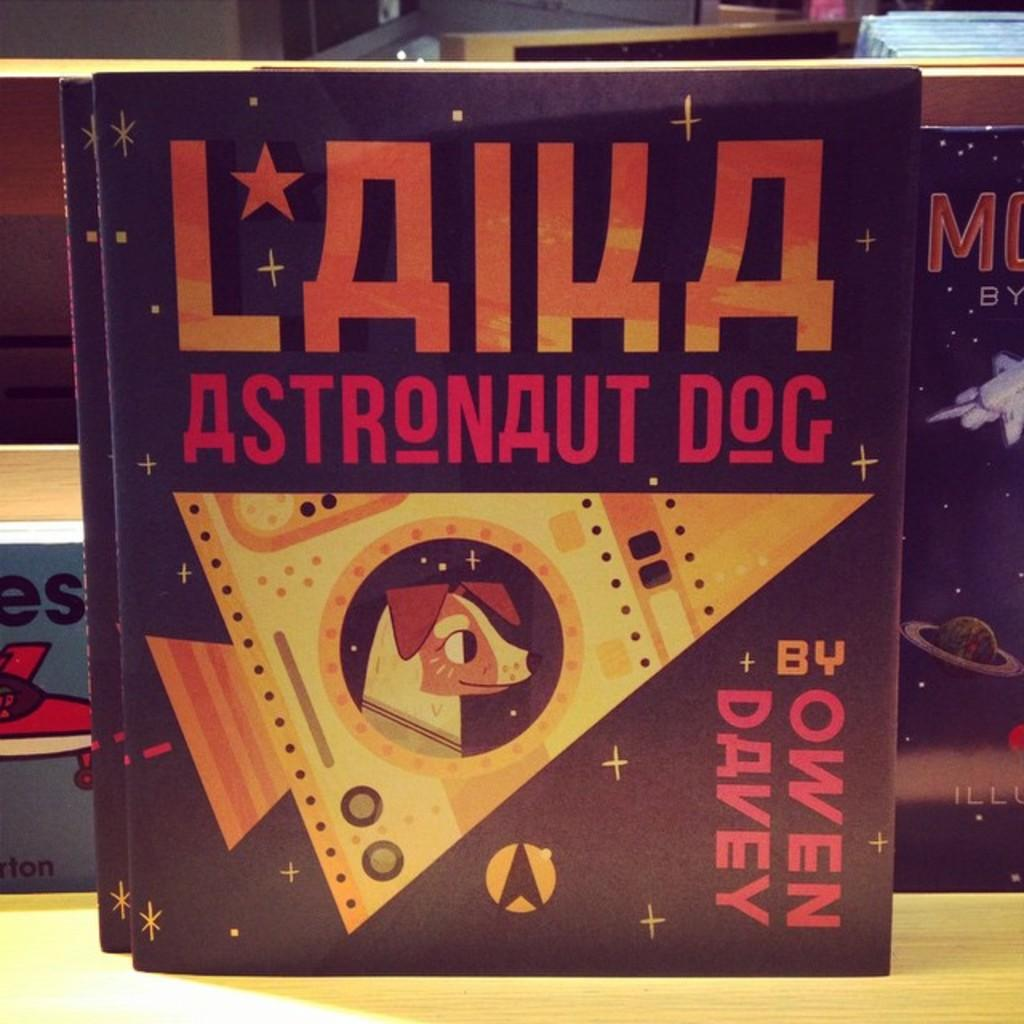<image>
Render a clear and concise summary of the photo. A book by Owen Davey titled "Laika Astronaut Dog". 